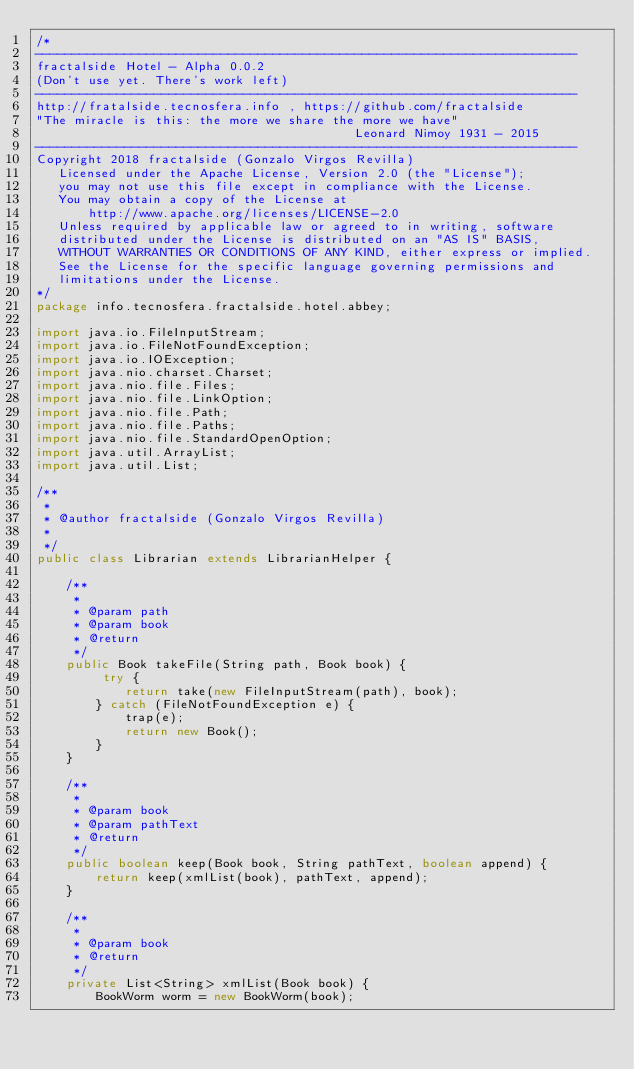<code> <loc_0><loc_0><loc_500><loc_500><_Java_>/*
-------------------------------------------------------------------------
fractalside Hotel - Alpha 0.0.2
(Don't use yet. There's work left)
-------------------------------------------------------------------------
http://fratalside.tecnosfera.info , https://github.com/fractalside
"The miracle is this: the more we share the more we have" 
                                           Leonard Nimoy 1931 - 2015
-------------------------------------------------------------------------
Copyright 2018 fractalside (Gonzalo Virgos Revilla)
   Licensed under the Apache License, Version 2.0 (the "License");
   you may not use this file except in compliance with the License.
   You may obtain a copy of the License at
       http://www.apache.org/licenses/LICENSE-2.0
   Unless required by applicable law or agreed to in writing, software
   distributed under the License is distributed on an "AS IS" BASIS,
   WITHOUT WARRANTIES OR CONDITIONS OF ANY KIND, either express or implied.
   See the License for the specific language governing permissions and
   limitations under the License.
*/
package info.tecnosfera.fractalside.hotel.abbey;

import java.io.FileInputStream;
import java.io.FileNotFoundException;
import java.io.IOException;
import java.nio.charset.Charset;
import java.nio.file.Files;
import java.nio.file.LinkOption;
import java.nio.file.Path;
import java.nio.file.Paths;
import java.nio.file.StandardOpenOption;
import java.util.ArrayList;
import java.util.List;

/**
 * 
 * @author fractalside (Gonzalo Virgos Revilla)
 *
 */
public class Librarian extends LibrarianHelper {
	
	/**
	 * 
	 * @param path
	 * @param book
	 * @return
	 */
	public Book takeFile(String path, Book book) {
		 try {
			return take(new FileInputStream(path), book);
		} catch (FileNotFoundException e) {
			trap(e);
			return new Book();
		}
	}
	
	/**
	 * 
	 * @param book
	 * @param pathText
	 * @return
	 */
	public boolean keep(Book book, String pathText, boolean append) {
		return keep(xmlList(book), pathText, append);
	}
	
	/**
	 * 
	 * @param book
	 * @return
	 */
	private List<String> xmlList(Book book) {
		BookWorm worm = new BookWorm(book);</code> 